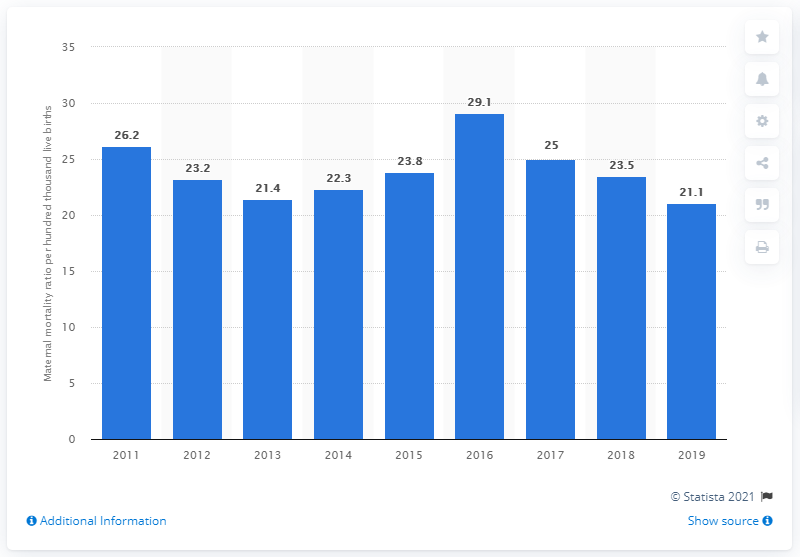List a handful of essential elements in this visual. In 2019, the maternal mortality ratio in Malaysia was 21.1. 